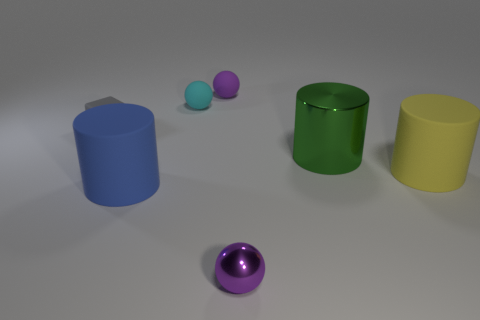Subtract all big blue matte cylinders. How many cylinders are left? 2 Subtract all purple spheres. How many spheres are left? 1 Add 2 small things. How many objects exist? 9 Subtract 2 cylinders. How many cylinders are left? 1 Subtract all cubes. How many objects are left? 6 Subtract all green cubes. Subtract all cyan cylinders. How many cubes are left? 1 Subtract all gray blocks. How many cyan spheres are left? 1 Subtract all small gray shiny cylinders. Subtract all purple objects. How many objects are left? 5 Add 2 rubber balls. How many rubber balls are left? 4 Add 3 cyan spheres. How many cyan spheres exist? 4 